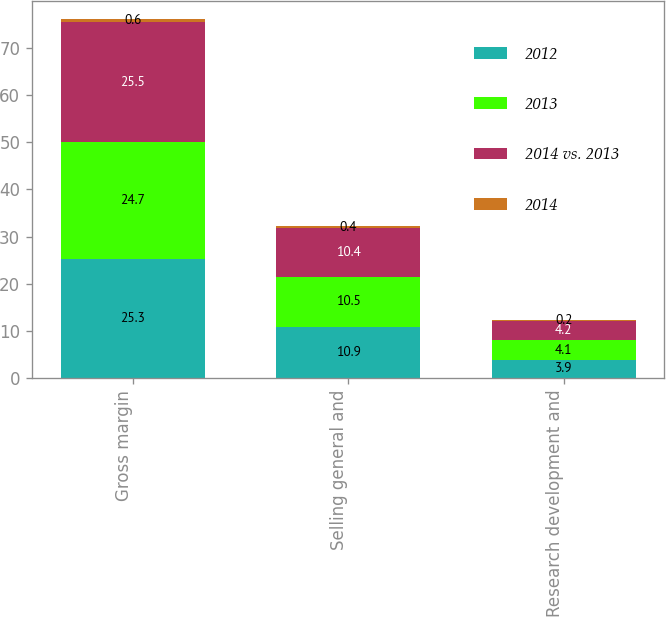Convert chart to OTSL. <chart><loc_0><loc_0><loc_500><loc_500><stacked_bar_chart><ecel><fcel>Gross margin<fcel>Selling general and<fcel>Research development and<nl><fcel>2012<fcel>25.3<fcel>10.9<fcel>3.9<nl><fcel>2013<fcel>24.7<fcel>10.5<fcel>4.1<nl><fcel>2014 vs. 2013<fcel>25.5<fcel>10.4<fcel>4.2<nl><fcel>2014<fcel>0.6<fcel>0.4<fcel>0.2<nl></chart> 